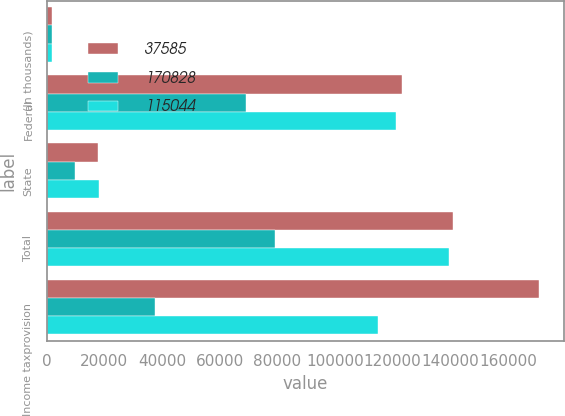Convert chart. <chart><loc_0><loc_0><loc_500><loc_500><stacked_bar_chart><ecel><fcel>(In thousands)<fcel>Federal<fcel>State<fcel>Total<fcel>Income taxprovision<nl><fcel>37585<fcel>2010<fcel>123215<fcel>17852<fcel>141067<fcel>170828<nl><fcel>170828<fcel>2009<fcel>69095<fcel>9992<fcel>79087<fcel>37585<nl><fcel>115044<fcel>2008<fcel>121274<fcel>18175<fcel>139449<fcel>115044<nl></chart> 